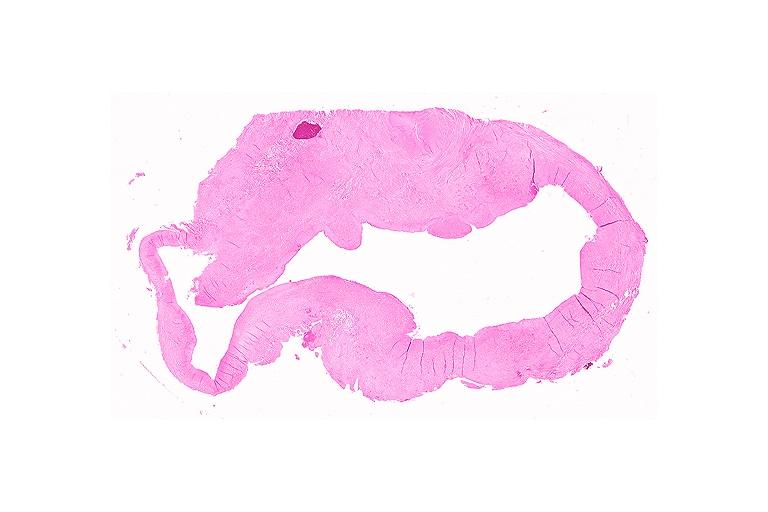what is present?
Answer the question using a single word or phrase. Oral 